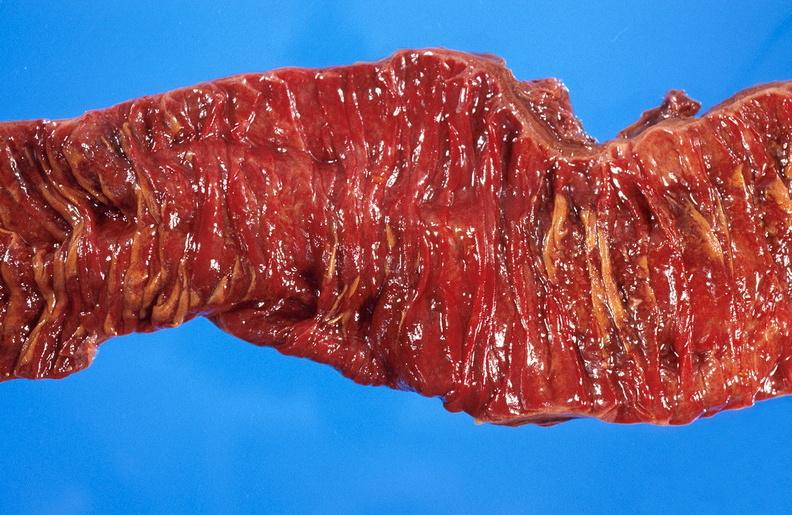s autoimmune thyroiditis present?
Answer the question using a single word or phrase. No 